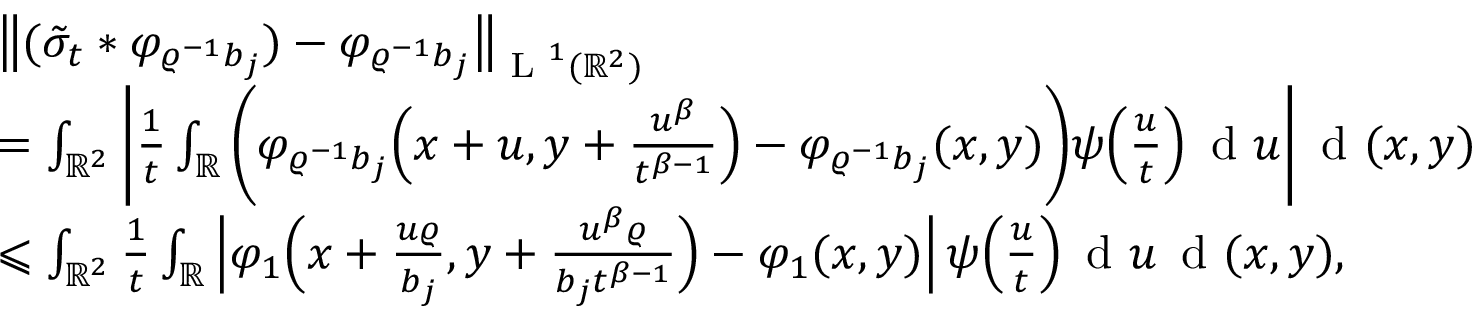Convert formula to latex. <formula><loc_0><loc_0><loc_500><loc_500>\begin{array} { r l } & { \left \| ( \tilde { \sigma } _ { t } \ast \varphi _ { \varrho ^ { - 1 } b _ { j } } ) - \varphi _ { \varrho ^ { - 1 } b _ { j } } \right \| _ { L ^ { 1 } ( \mathbb { R } ^ { 2 } ) } } \\ & { = \int _ { \mathbb { R } ^ { 2 } } \left | \frac { 1 } { t } \int _ { \mathbb { R } } \left ( \varphi _ { \varrho ^ { - 1 } b _ { j } } \left ( x + u , y + \frac { u ^ { \beta } } { t ^ { \beta - 1 } } \right ) - \varphi _ { \varrho ^ { - 1 } b _ { j } } ( x , y ) \right ) \psi \left ( \frac { u } { t } \right ) \, d u \right | \, d ( x , y ) } \\ & { \leqslant \int _ { \mathbb { R } ^ { 2 } } \frac { 1 } { t } \int _ { \mathbb { R } } \left | \varphi _ { 1 } \left ( x + \frac { u \varrho } { b _ { j } } , y + \frac { u ^ { \beta } \varrho } { b _ { j } t ^ { \beta - 1 } } \right ) - \varphi _ { 1 } ( x , y ) \right | \, \psi \left ( \frac { u } { t } \right ) \, d u \, d ( x , y ) , } \end{array}</formula> 